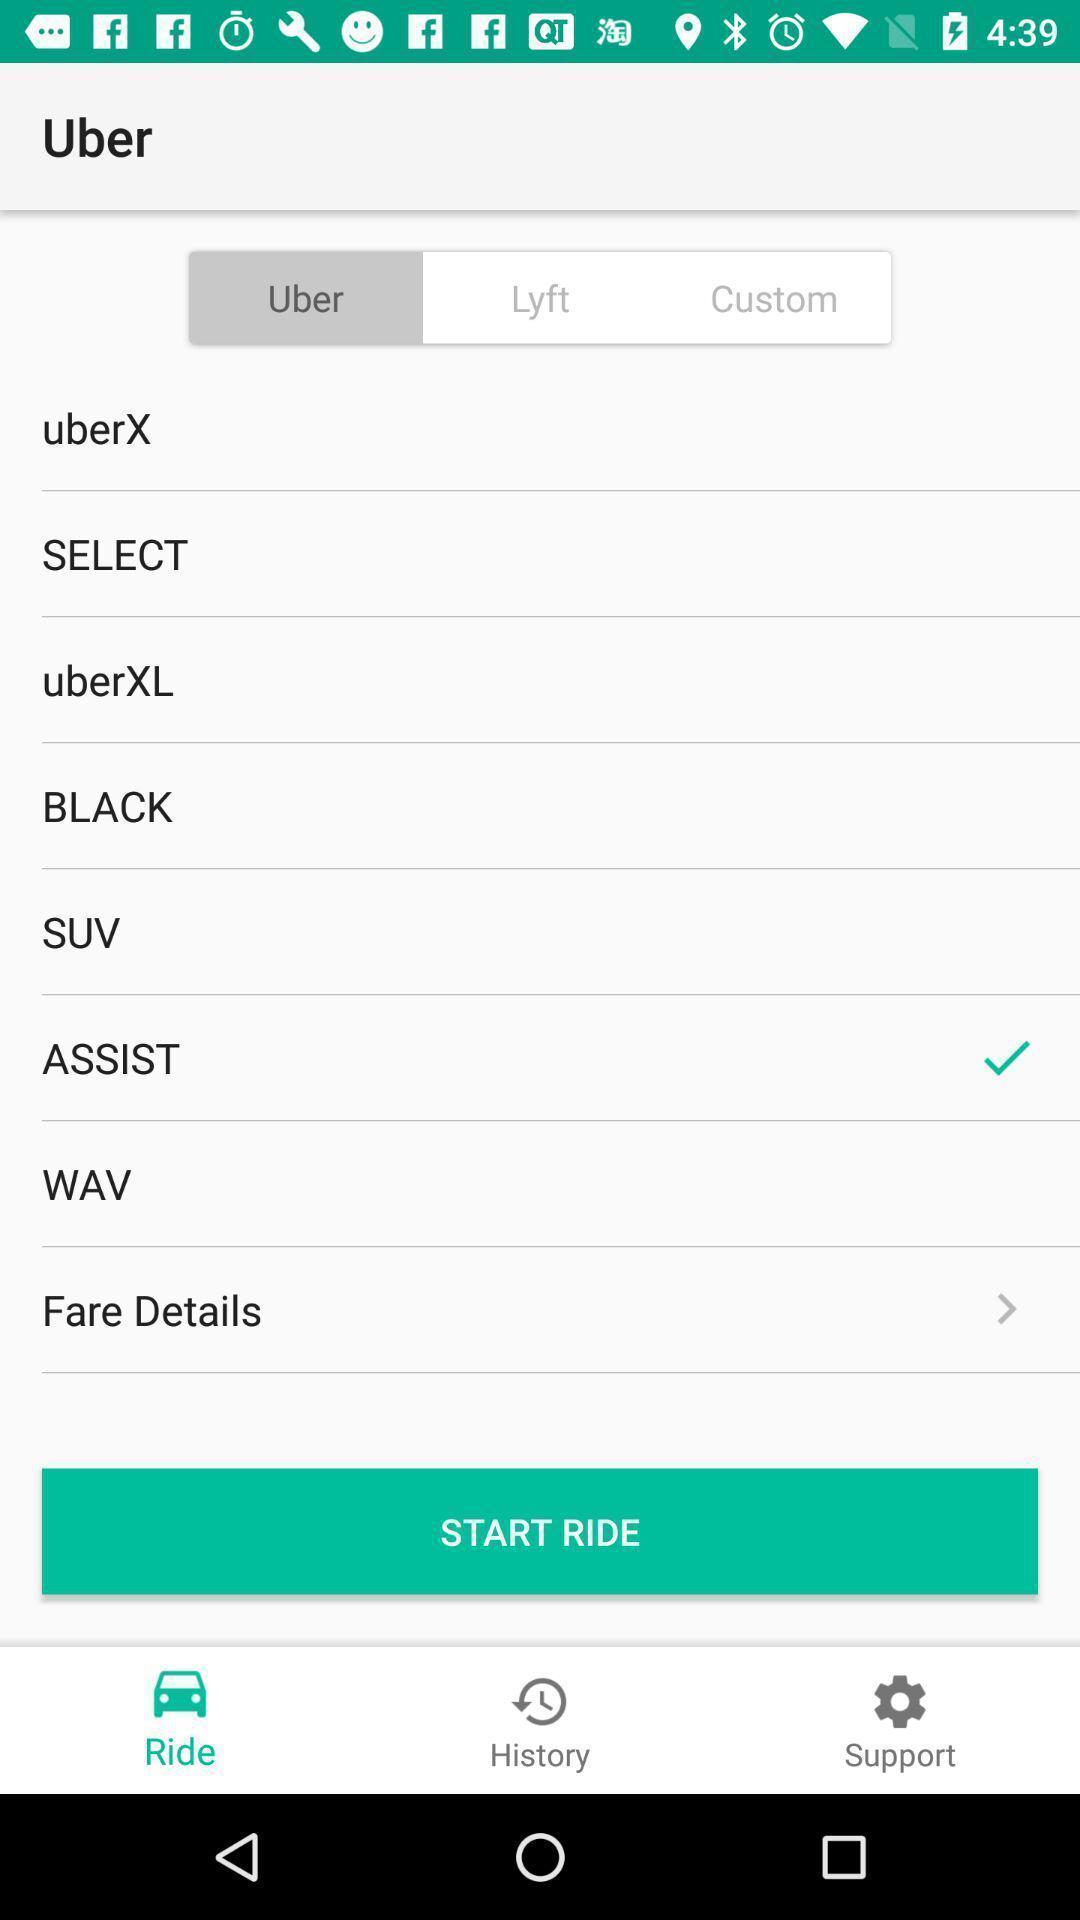Give me a summary of this screen capture. Screen shows multiple options in travel application. 